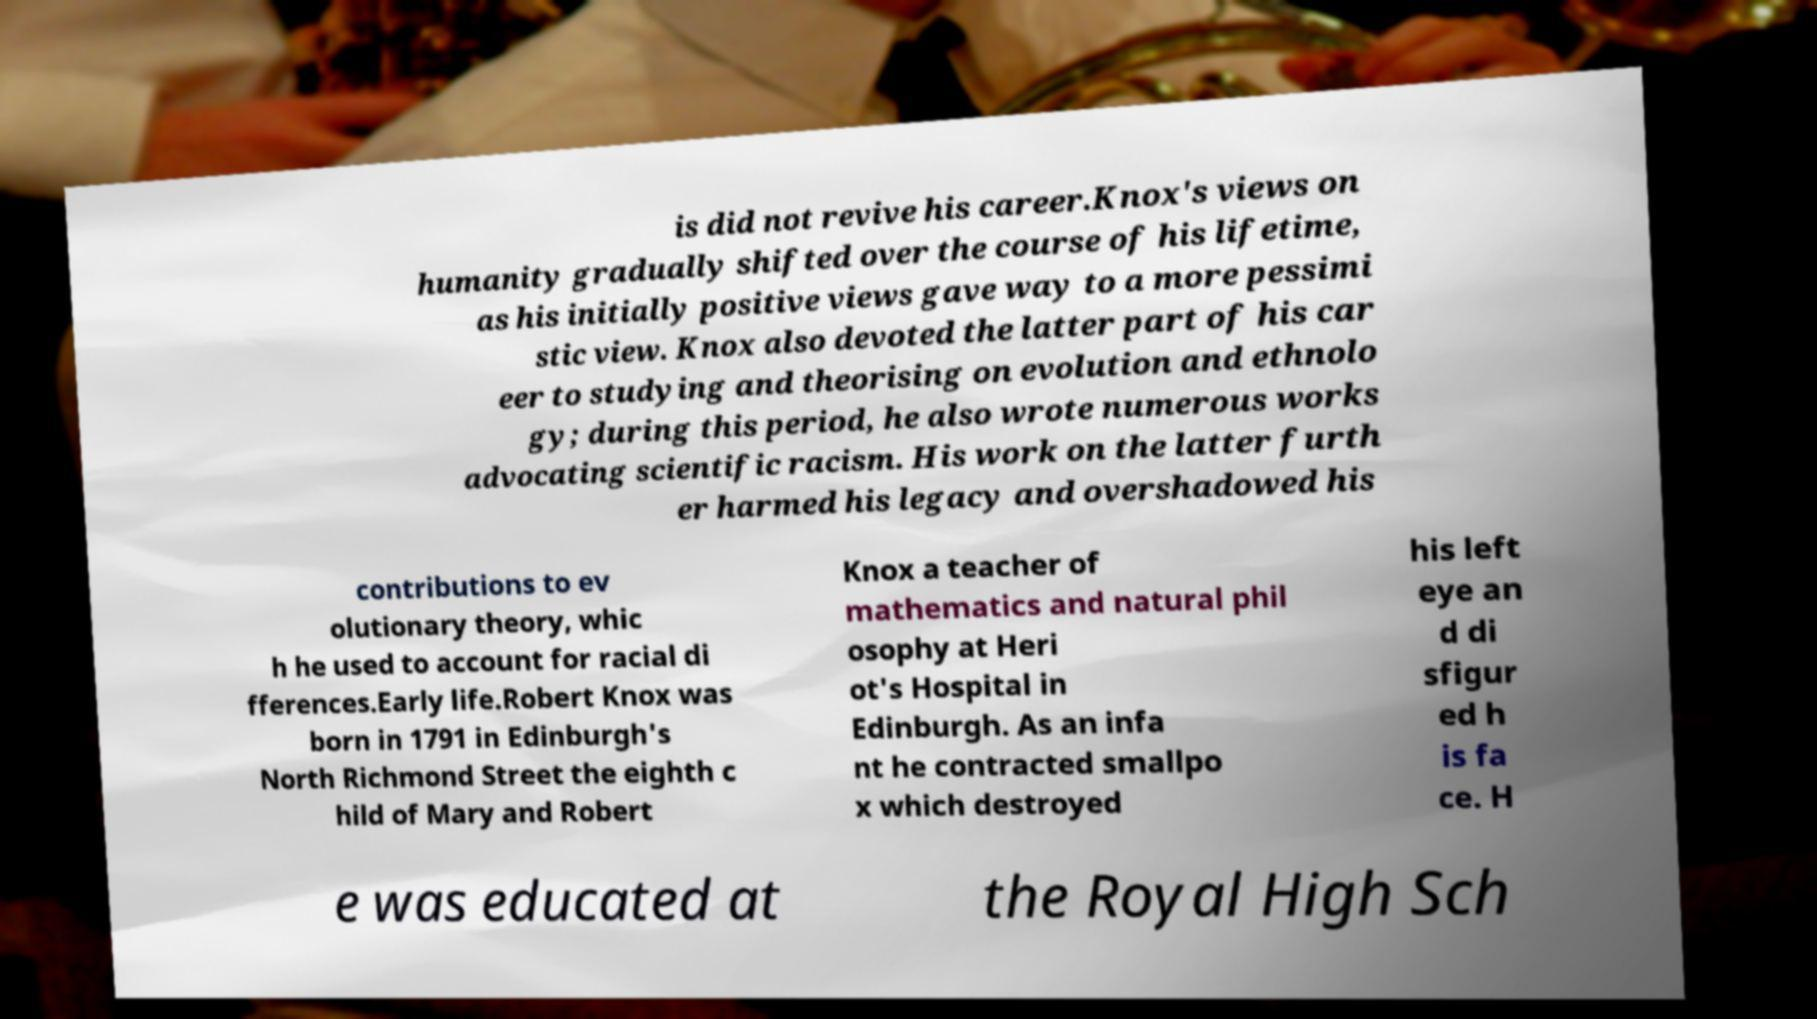Please read and relay the text visible in this image. What does it say? is did not revive his career.Knox's views on humanity gradually shifted over the course of his lifetime, as his initially positive views gave way to a more pessimi stic view. Knox also devoted the latter part of his car eer to studying and theorising on evolution and ethnolo gy; during this period, he also wrote numerous works advocating scientific racism. His work on the latter furth er harmed his legacy and overshadowed his contributions to ev olutionary theory, whic h he used to account for racial di fferences.Early life.Robert Knox was born in 1791 in Edinburgh's North Richmond Street the eighth c hild of Mary and Robert Knox a teacher of mathematics and natural phil osophy at Heri ot's Hospital in Edinburgh. As an infa nt he contracted smallpo x which destroyed his left eye an d di sfigur ed h is fa ce. H e was educated at the Royal High Sch 